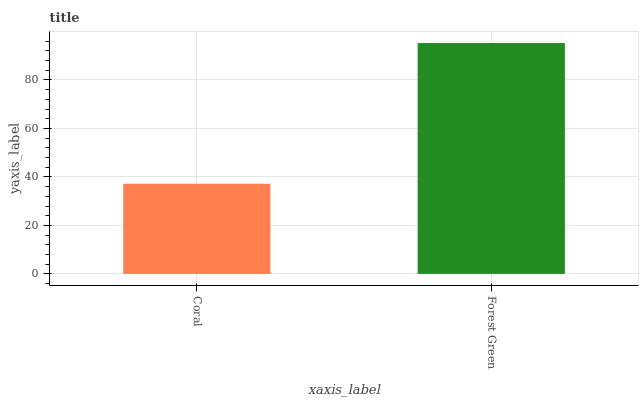Is Forest Green the minimum?
Answer yes or no. No. Is Forest Green greater than Coral?
Answer yes or no. Yes. Is Coral less than Forest Green?
Answer yes or no. Yes. Is Coral greater than Forest Green?
Answer yes or no. No. Is Forest Green less than Coral?
Answer yes or no. No. Is Forest Green the high median?
Answer yes or no. Yes. Is Coral the low median?
Answer yes or no. Yes. Is Coral the high median?
Answer yes or no. No. Is Forest Green the low median?
Answer yes or no. No. 